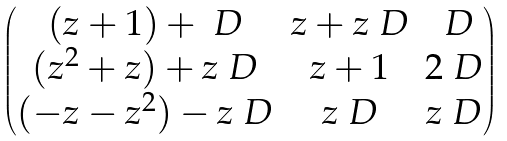<formula> <loc_0><loc_0><loc_500><loc_500>\begin{pmatrix} ( z + 1 ) + \ D & z + z \ D & \ D \\ ( z ^ { 2 } + z ) + z \ D & z + 1 & 2 \ D \\ ( - z - z ^ { 2 } ) - z \ D & z \ D & z \ D \end{pmatrix}</formula> 